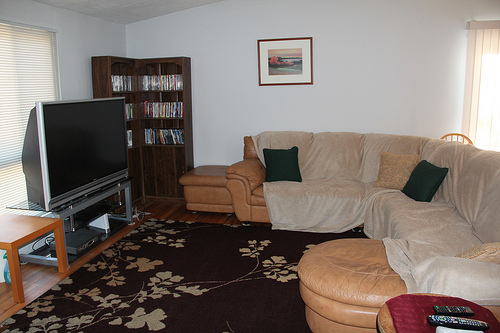Please provide a short description for this region: [0.06, 0.37, 0.27, 0.56]. The identified region clearly shows a large flat-screen TV, which is a central entertainment feature in the living room. 